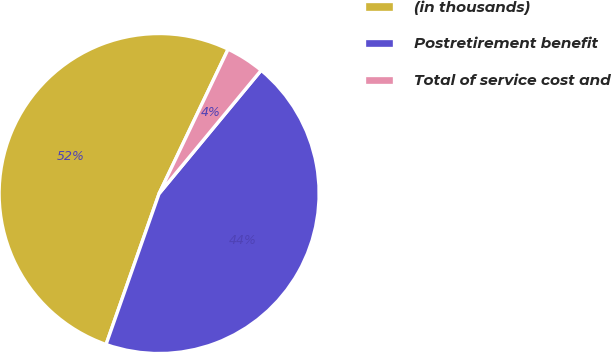<chart> <loc_0><loc_0><loc_500><loc_500><pie_chart><fcel>(in thousands)<fcel>Postretirement benefit<fcel>Total of service cost and<nl><fcel>51.71%<fcel>44.37%<fcel>3.91%<nl></chart> 